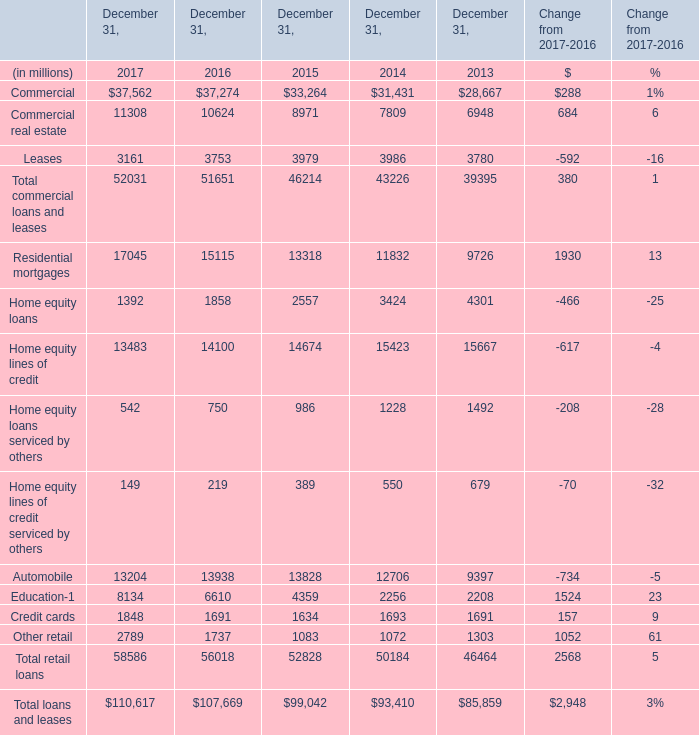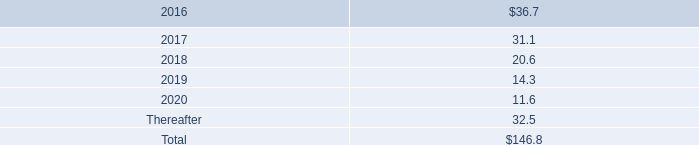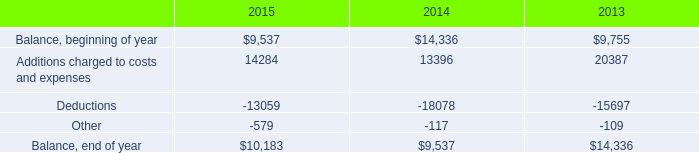In which year the Total retail loans is positive? 
Answer: 2017. 